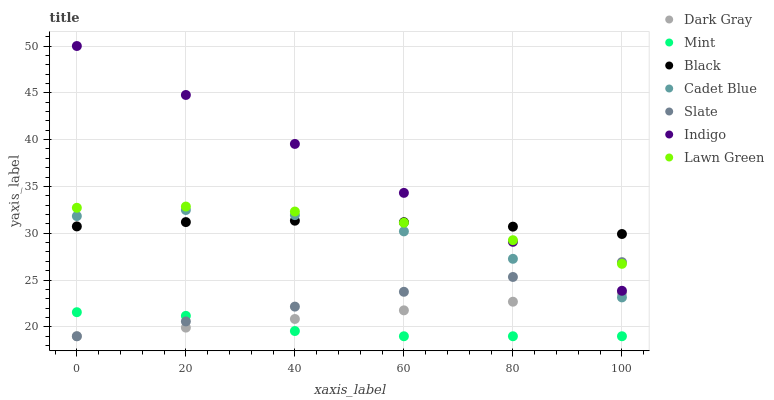Does Mint have the minimum area under the curve?
Answer yes or no. Yes. Does Indigo have the maximum area under the curve?
Answer yes or no. Yes. Does Cadet Blue have the minimum area under the curve?
Answer yes or no. No. Does Cadet Blue have the maximum area under the curve?
Answer yes or no. No. Is Slate the smoothest?
Answer yes or no. Yes. Is Cadet Blue the roughest?
Answer yes or no. Yes. Is Indigo the smoothest?
Answer yes or no. No. Is Indigo the roughest?
Answer yes or no. No. Does Slate have the lowest value?
Answer yes or no. Yes. Does Cadet Blue have the lowest value?
Answer yes or no. No. Does Indigo have the highest value?
Answer yes or no. Yes. Does Cadet Blue have the highest value?
Answer yes or no. No. Is Cadet Blue less than Indigo?
Answer yes or no. Yes. Is Indigo greater than Cadet Blue?
Answer yes or no. Yes. Does Mint intersect Dark Gray?
Answer yes or no. Yes. Is Mint less than Dark Gray?
Answer yes or no. No. Is Mint greater than Dark Gray?
Answer yes or no. No. Does Cadet Blue intersect Indigo?
Answer yes or no. No. 